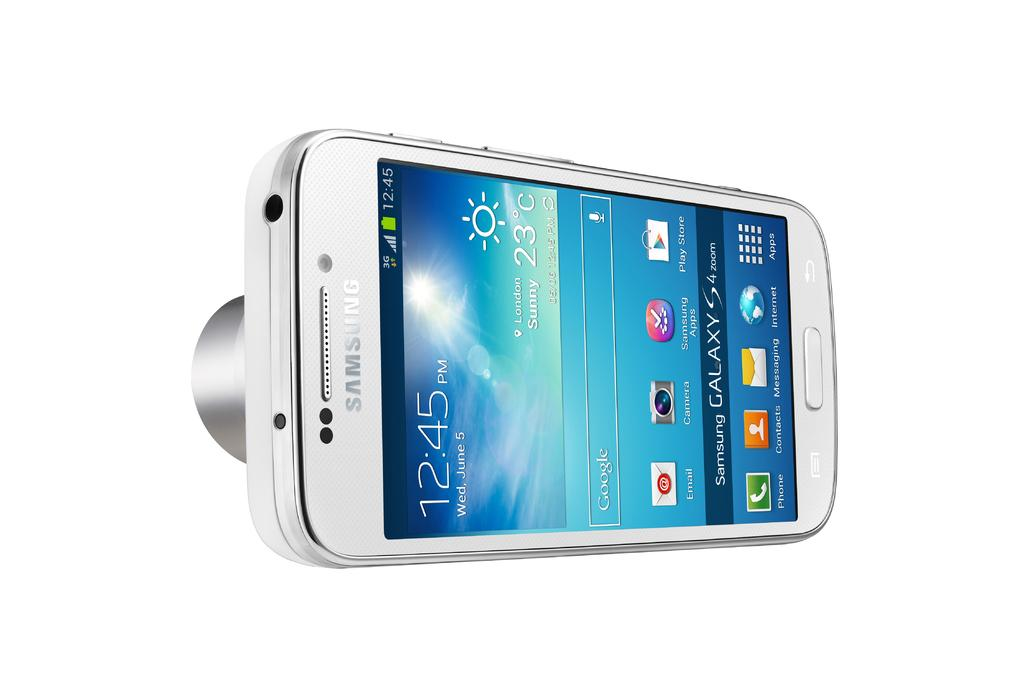<image>
Render a clear and concise summary of the photo. A white Samsung brand smartphone in the model Galaxy S4 with the time displaying 12:45pm 